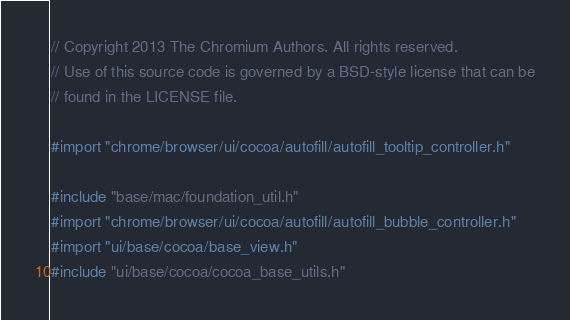<code> <loc_0><loc_0><loc_500><loc_500><_ObjectiveC_>// Copyright 2013 The Chromium Authors. All rights reserved.
// Use of this source code is governed by a BSD-style license that can be
// found in the LICENSE file.

#import "chrome/browser/ui/cocoa/autofill/autofill_tooltip_controller.h"

#include "base/mac/foundation_util.h"
#import "chrome/browser/ui/cocoa/autofill/autofill_bubble_controller.h"
#import "ui/base/cocoa/base_view.h"
#include "ui/base/cocoa/cocoa_base_utils.h"</code> 